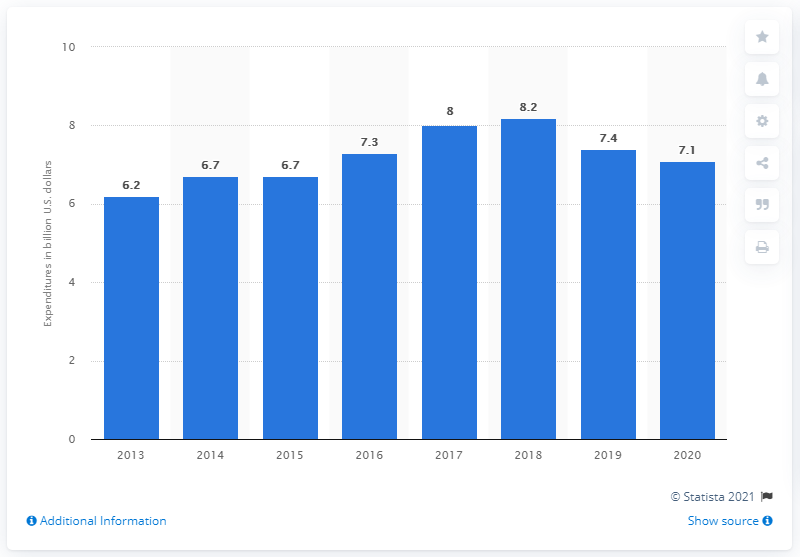Point out several critical features in this image. In 2020, Ford invested $7.1 billion in research and development. 